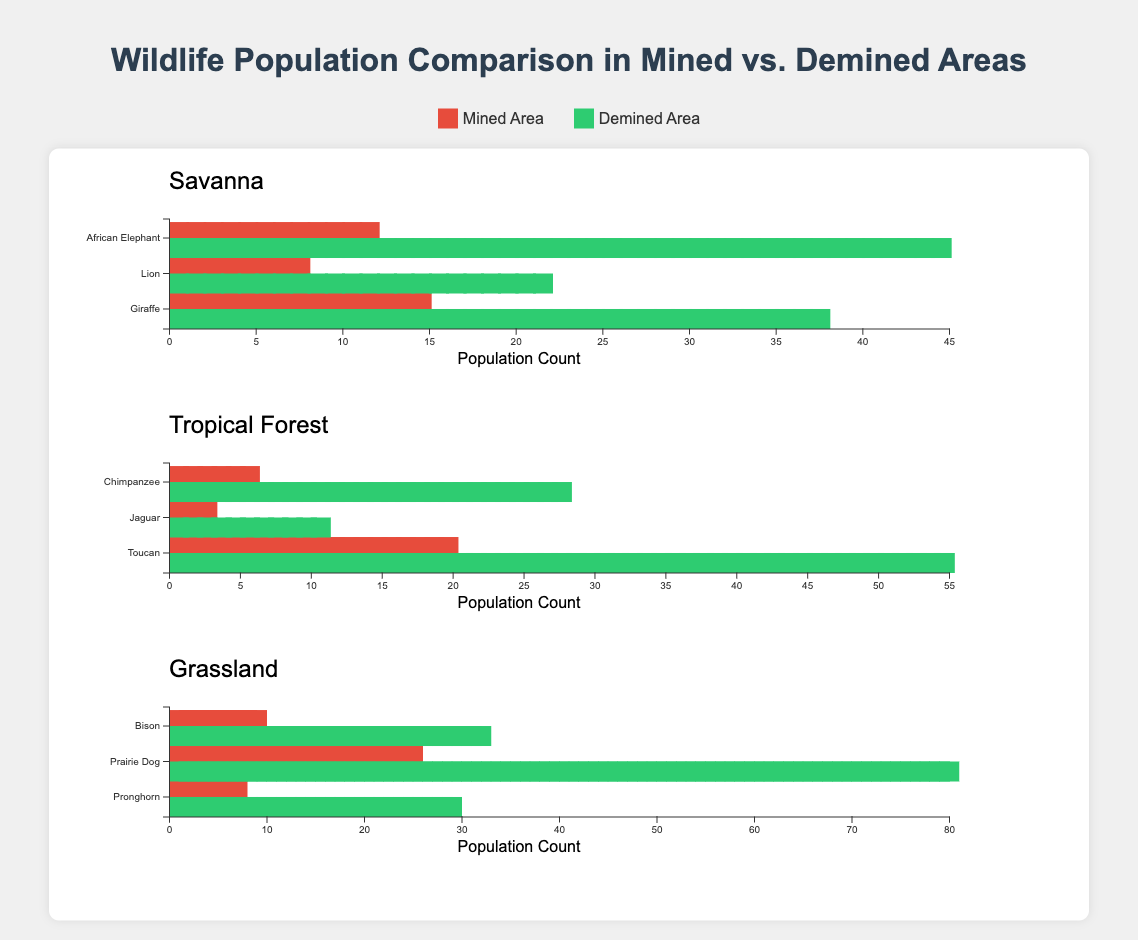Which habitat has the highest number of species listed? To determine which habitat has the highest number of species, you can count the number of species for each habitat shown in the figure. The Savanna, Tropical Forest, and Grassland all have 3 species listed.
Answer: All habitats have 3 species listed What's the total population count for African Elephants in mined and demined Savanna areas? Add the population counts in mined (12) and demined (45) areas together. The total count for African Elephants in Savanna is 12 + 45 = 57.
Answer: 57 Which species shows the greatest difference in population between mined and demined areas in the Tropical Forest? Calculate the differences for all species in the Tropical Forest: Chimpanzee (28-6=22), Jaguar (11-3=8), and Toucan (55-20=35). The Toucan shows the greatest difference.
Answer: Toucan How does the population of Lions in mined areas compare to that of Jaguars in mined areas? Compare the population counts directly. Lions in mined areas have a population of 8, while Jaguars have a population of 3. Lions have a higher population in mined areas compared to Jaguars.
Answer: Lions have a higher population What is the average population count for each species in the Grassland habitat in the mined areas? The population counts for Bison, Prairie Dog, and Pronghorn in the mined areas are 9, 25, and 7 respectively. Add these numbers and divide by the number of species: (9 + 25 + 7)/3 = 41/3 ≈ 13.67.
Answer: About 13.67 Which animal has the largest population in the demined Savanna habitat? Look at the populations in the demined Savanna area: African Elephant (45), Lion (22), and Giraffe (38). The African Elephant has the largest population.
Answer: African Elephant Is there a species in any habitat where the population is equal in both mined and demined areas? Scan through the populations for each species in the mined and demined areas across all habitats. There is no species with equal populations in both areas.
Answer: No What is the ratio of mined to demined population for Prairie Dogs in the Grassland? For Prairie Dogs, the mined area population is 25 and the demined area population is 80. The ratio is 25:80, which simplifies to 5:16.
Answer: 5:16 